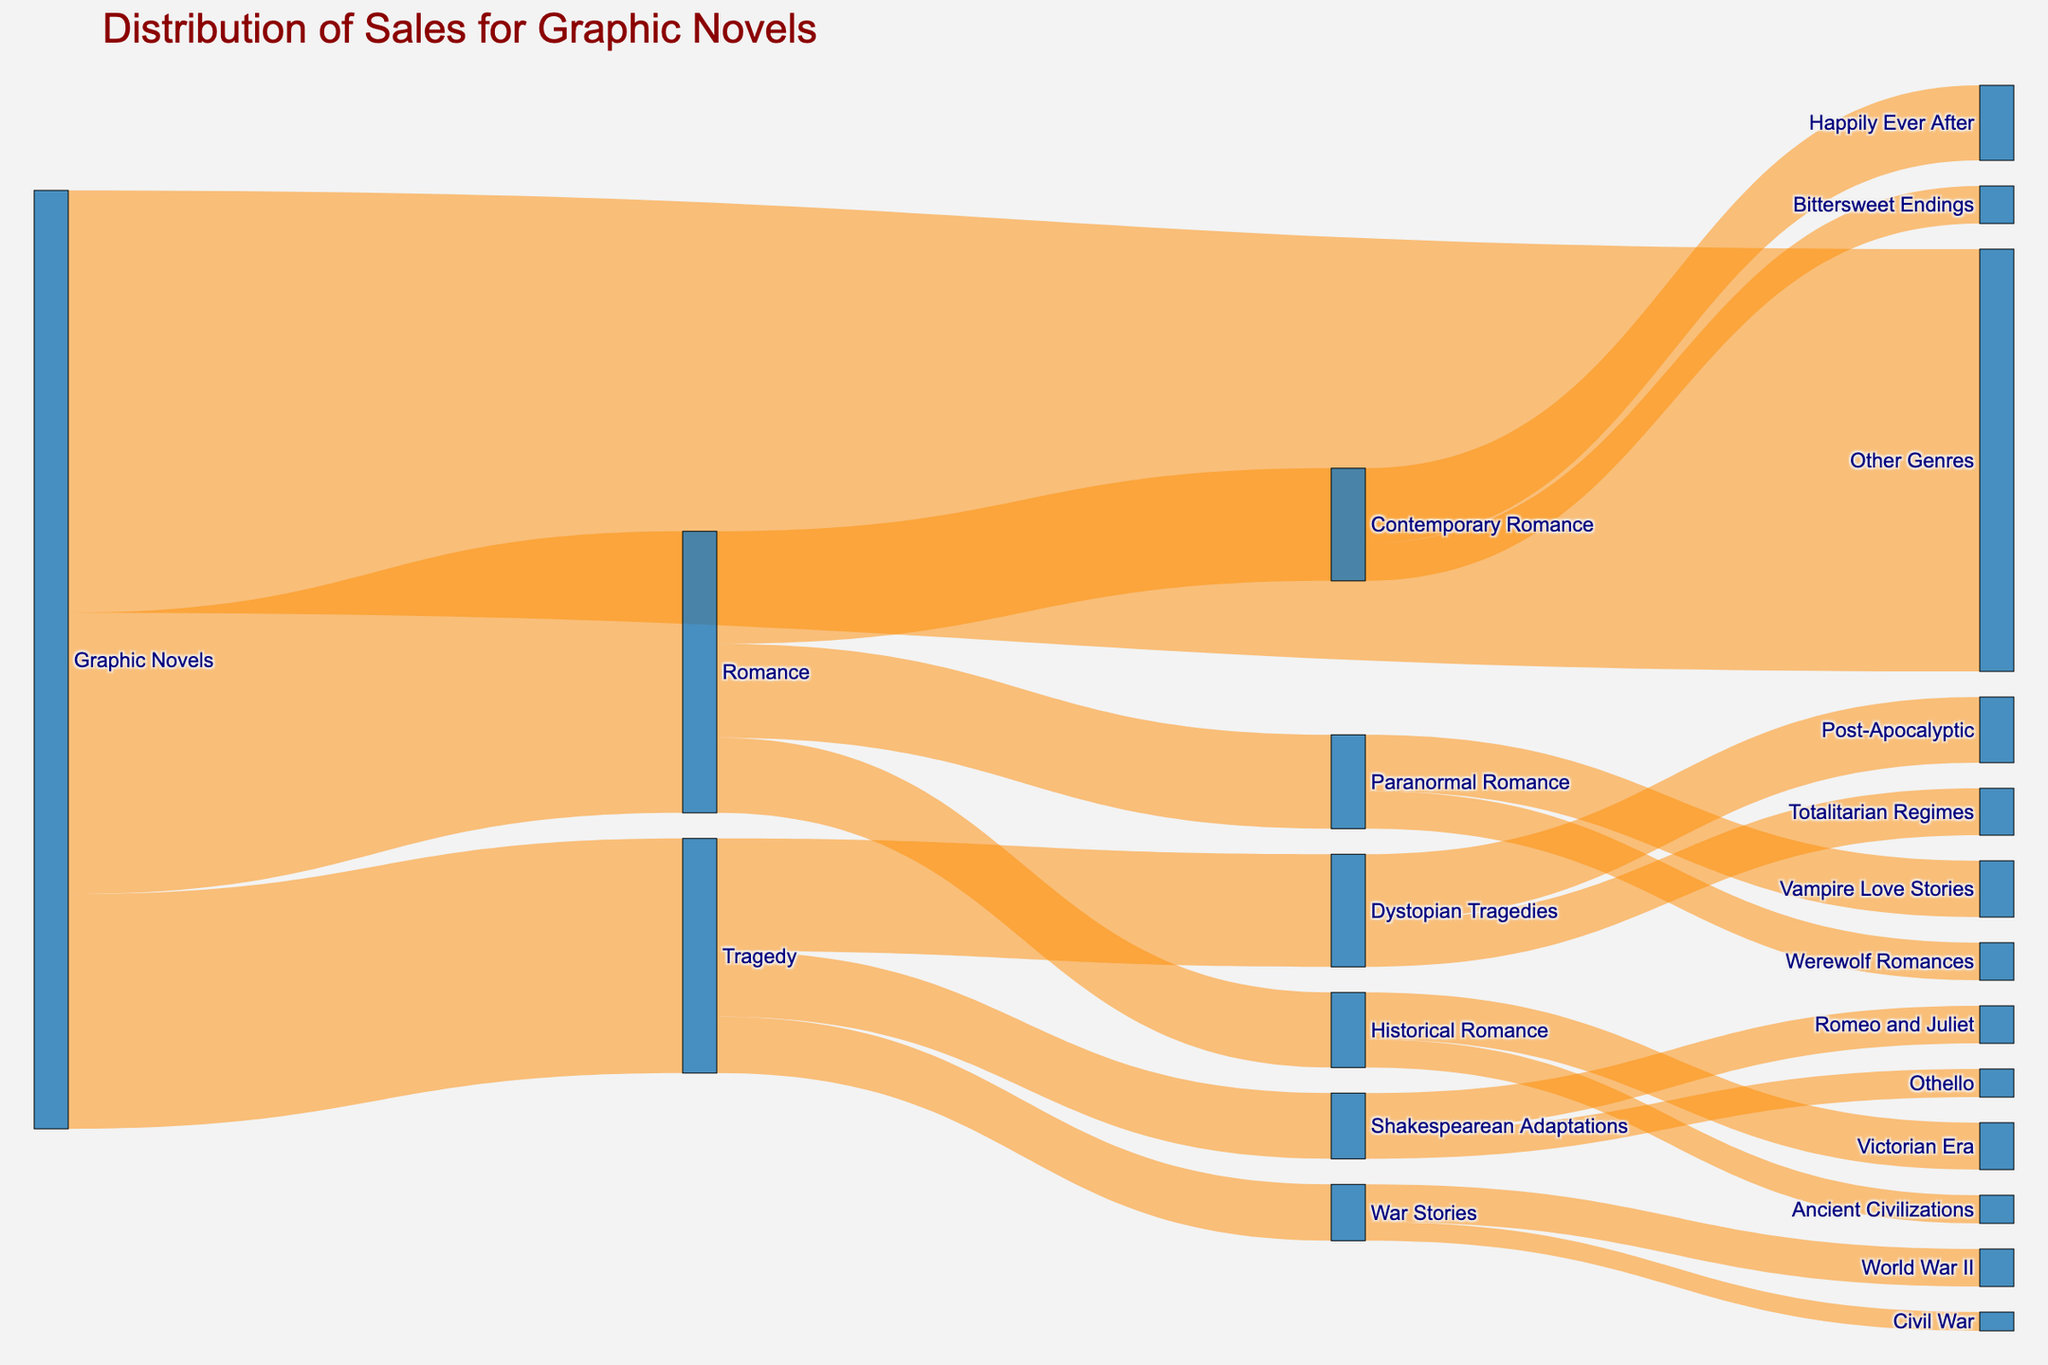What's the overall title of the figure? The title of the figure is written at the top in larger, bold text. The title summarizes the main content or purpose of the graphic. Here, it reads "Distribution of Sales for Graphic Novels".
Answer: Distribution of Sales for Graphic Novels Which genre has more sales, Romance or Tragedy? The Sankey diagram shows flows from "Graphic Novels" to different genres. By comparing the values assigned to the links, we can see that Romance has a value of 30, while Tragedy has a value of 25.
Answer: Romance What percentage of graphic novels sales are in the "Other Genres"? From the Sankey diagram, "Other Genres" has a value of 45 out of the total sales (30 from Romance + 25 from Tragedy + 45 from Other Genres = 100). So, the percentage is (45/100)*100 = 45%.
Answer: 45% Which sub-genre has the highest sales within the Tragedy genre? Focusing on the links coming out of "Tragedy", we see the three sub-genres: Shakespearean Adaptations (7), War Stories (6), and Dystopian Tragedies (12). The highest value is for Dystopian Tragedies.
Answer: Dystopian Tragedies What is the total sales value for all the sub-genres under Romance? The sub-genres under Romance are Contemporary Romance (12), Historical Romance (8), and Paranormal Romance (10). Adding these together: 12 + 8 + 10 = 30.
Answer: 30 Compare the sales between "Vampire Love Stories" in Paranormal Romance and "Romeo and Juliet" in Shakespearean Adaptations. From Paranormal Romance, Vampire Love Stories have sales of 6. In Shakespearean Adaptations, Romeo and Juliet have sales of 4. Hence, Vampire Love Stories have higher sales.
Answer: Vampire Love Stories How many categories are there under "Dystopian Tragedies"? Observing the Dystopian Tragedies node, there are two links showing sales distributions: Post-Apocalyptic (7) and Totalitarian Regimes (5). Thus, there are 2 categories.
Answer: 2 What proportion of Contemporary Romance has a "Happily Ever After" ending? Contemporary Romance has a total sales volume of 12, split between Happily Ever After (8) and Bittersweet Endings (4). The proportion is calculated as 8/12.
Answer: 2/3 Which has more sales: "Historical Romance in the Victorian Era" or "World War II War Stories"? Historical Romance in the Victorian Era has sales of 5, while World War II War Stories have sales of 4. Comparing these values, Historical Romance in the Victorian Era has more sales.
Answer: Historical Romance in the Victorian Era What's the difference in sales between "Civil War Stories" and "Ancient Civilizations Historical Romance"? Civil War Stories have a sales value of 2, while Ancient Civilizations Historical Romance has a value of 3. The difference is calculated as 3 - 2 = 1.
Answer: 1 